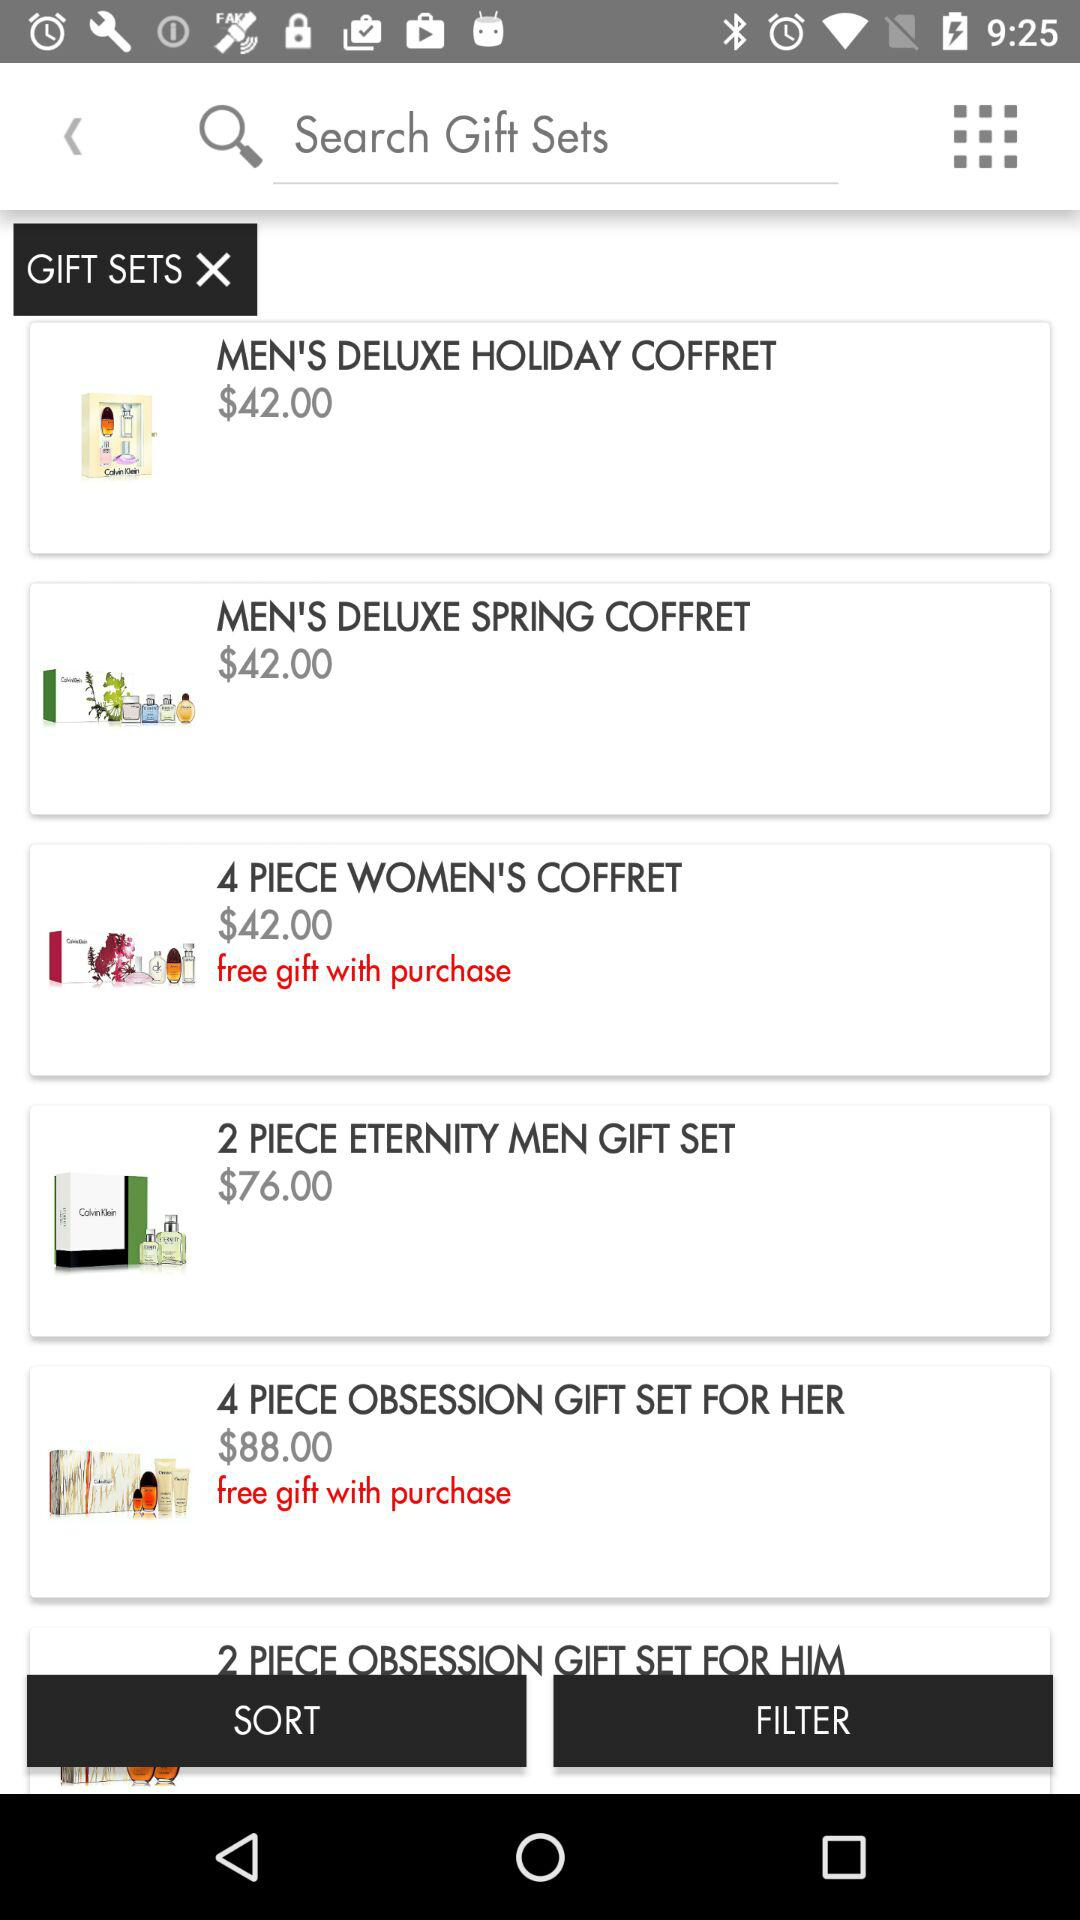Which gift sets offer free gifts? The gift sets are "4 PIECE WOMEN'S COFFRET" and "4 PIECE OBSESSION GIFT SET FOR HER". 